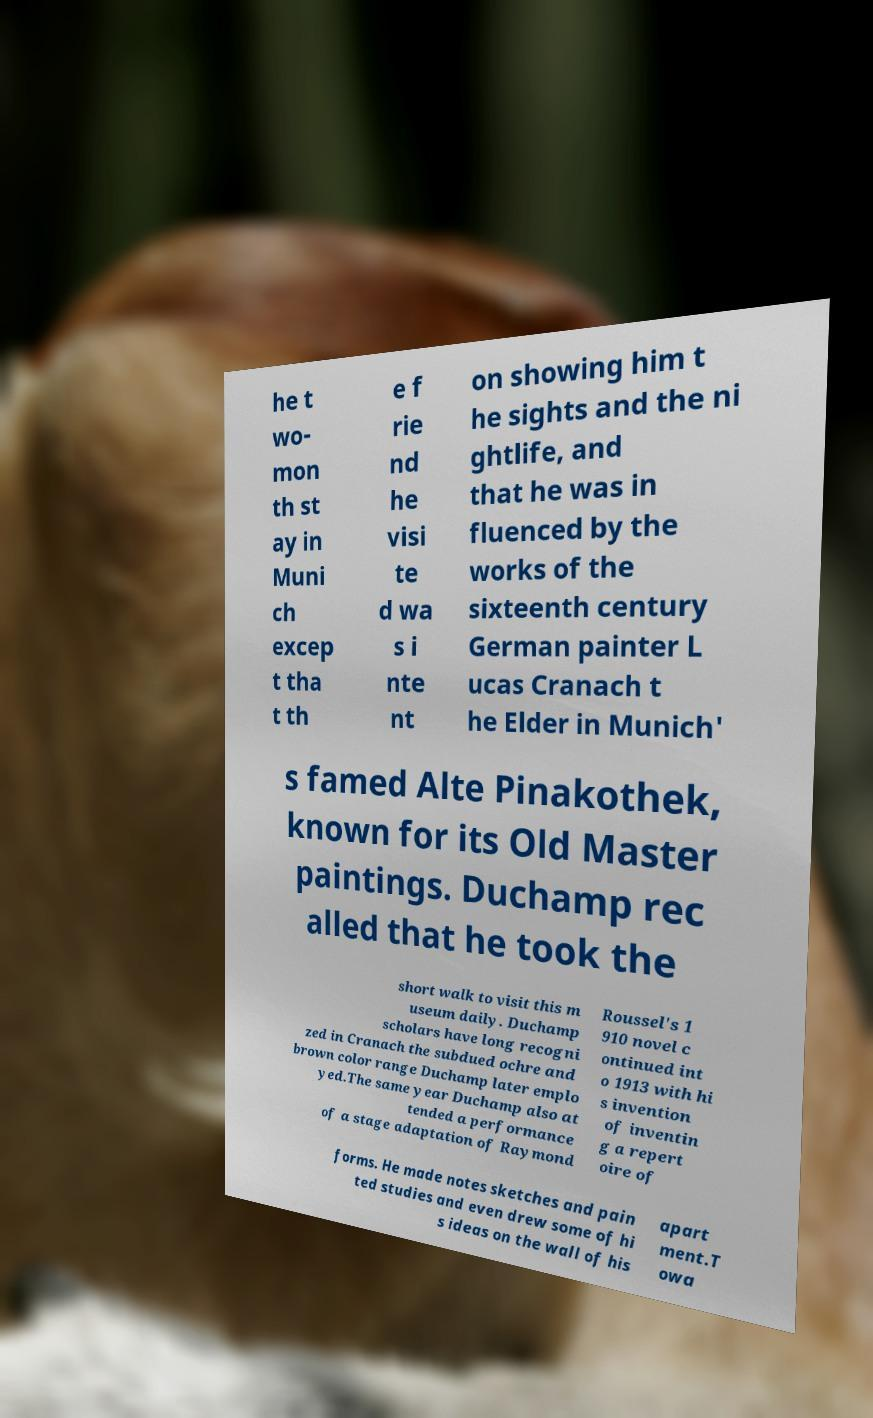Please identify and transcribe the text found in this image. he t wo- mon th st ay in Muni ch excep t tha t th e f rie nd he visi te d wa s i nte nt on showing him t he sights and the ni ghtlife, and that he was in fluenced by the works of the sixteenth century German painter L ucas Cranach t he Elder in Munich' s famed Alte Pinakothek, known for its Old Master paintings. Duchamp rec alled that he took the short walk to visit this m useum daily. Duchamp scholars have long recogni zed in Cranach the subdued ochre and brown color range Duchamp later emplo yed.The same year Duchamp also at tended a performance of a stage adaptation of Raymond Roussel's 1 910 novel c ontinued int o 1913 with hi s invention of inventin g a repert oire of forms. He made notes sketches and pain ted studies and even drew some of hi s ideas on the wall of his apart ment.T owa 